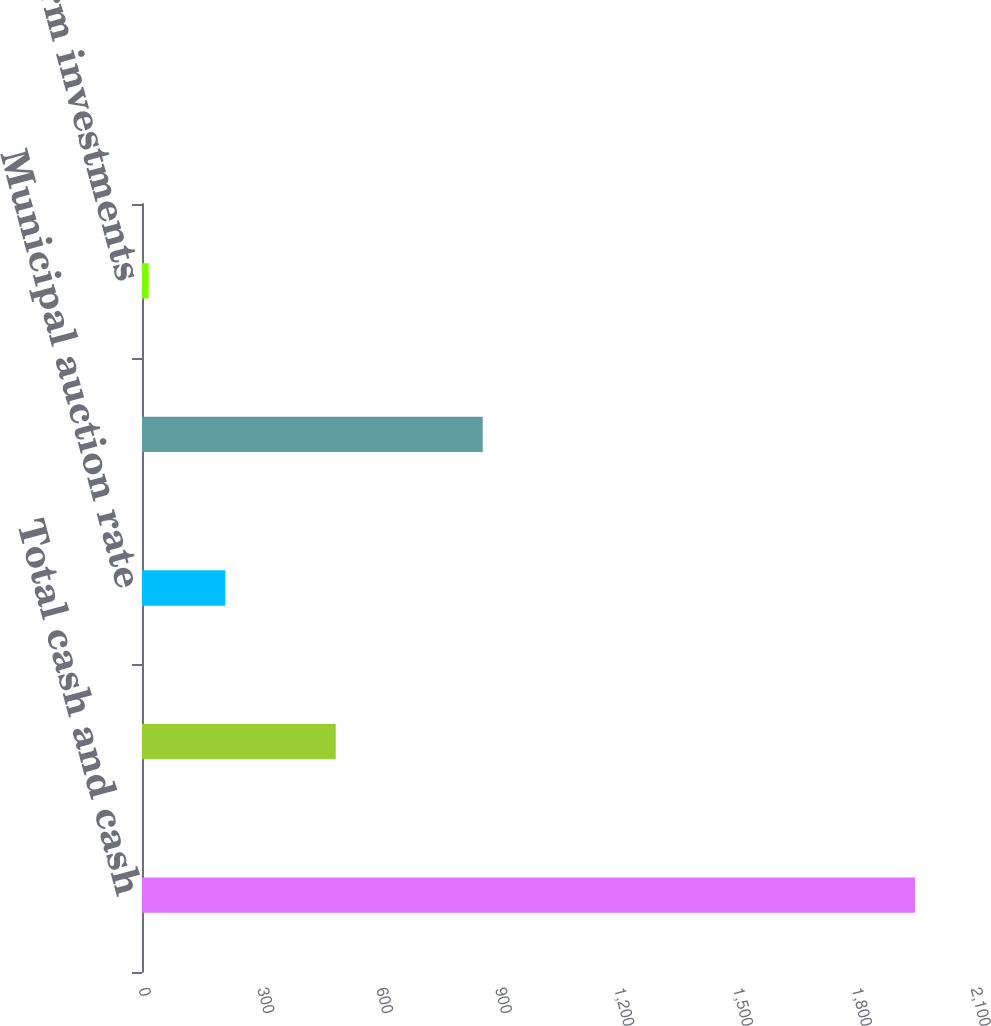Convert chart to OTSL. <chart><loc_0><loc_0><loc_500><loc_500><bar_chart><fcel>Total cash and cash<fcel>Municipal bonds<fcel>Municipal auction rate<fcel>Total available-for-sale debt<fcel>Other long-term investments<nl><fcel>1951<fcel>489<fcel>210.4<fcel>860<fcel>17<nl></chart> 